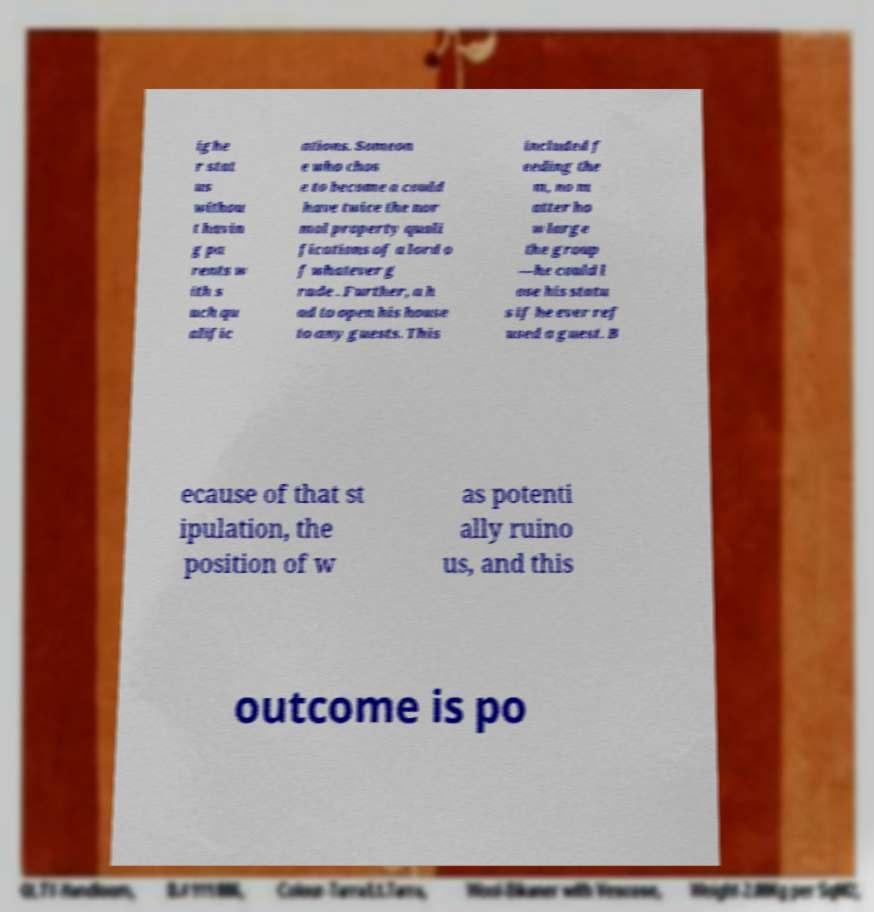What messages or text are displayed in this image? I need them in a readable, typed format. ighe r stat us withou t havin g pa rents w ith s uch qu alific ations. Someon e who chos e to become a could have twice the nor mal property quali fications of a lord o f whatever g rade . Further, a h ad to open his house to any guests. This included f eeding the m, no m atter ho w large the group —he could l ose his statu s if he ever ref used a guest. B ecause of that st ipulation, the position of w as potenti ally ruino us, and this outcome is po 